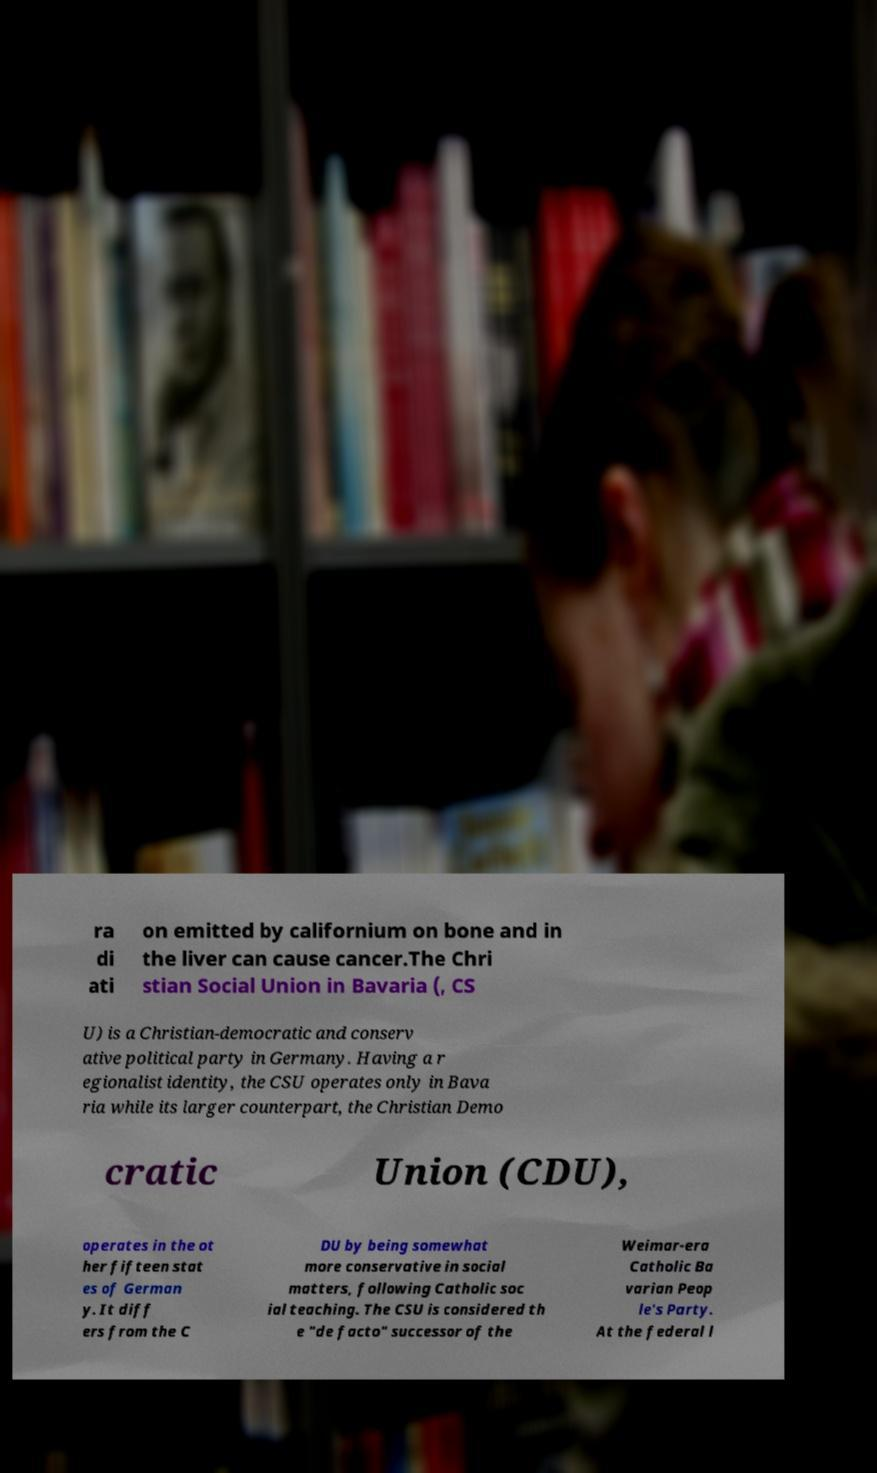Please read and relay the text visible in this image. What does it say? ra di ati on emitted by californium on bone and in the liver can cause cancer.The Chri stian Social Union in Bavaria (, CS U) is a Christian-democratic and conserv ative political party in Germany. Having a r egionalist identity, the CSU operates only in Bava ria while its larger counterpart, the Christian Demo cratic Union (CDU), operates in the ot her fifteen stat es of German y. It diff ers from the C DU by being somewhat more conservative in social matters, following Catholic soc ial teaching. The CSU is considered th e "de facto" successor of the Weimar-era Catholic Ba varian Peop le's Party. At the federal l 